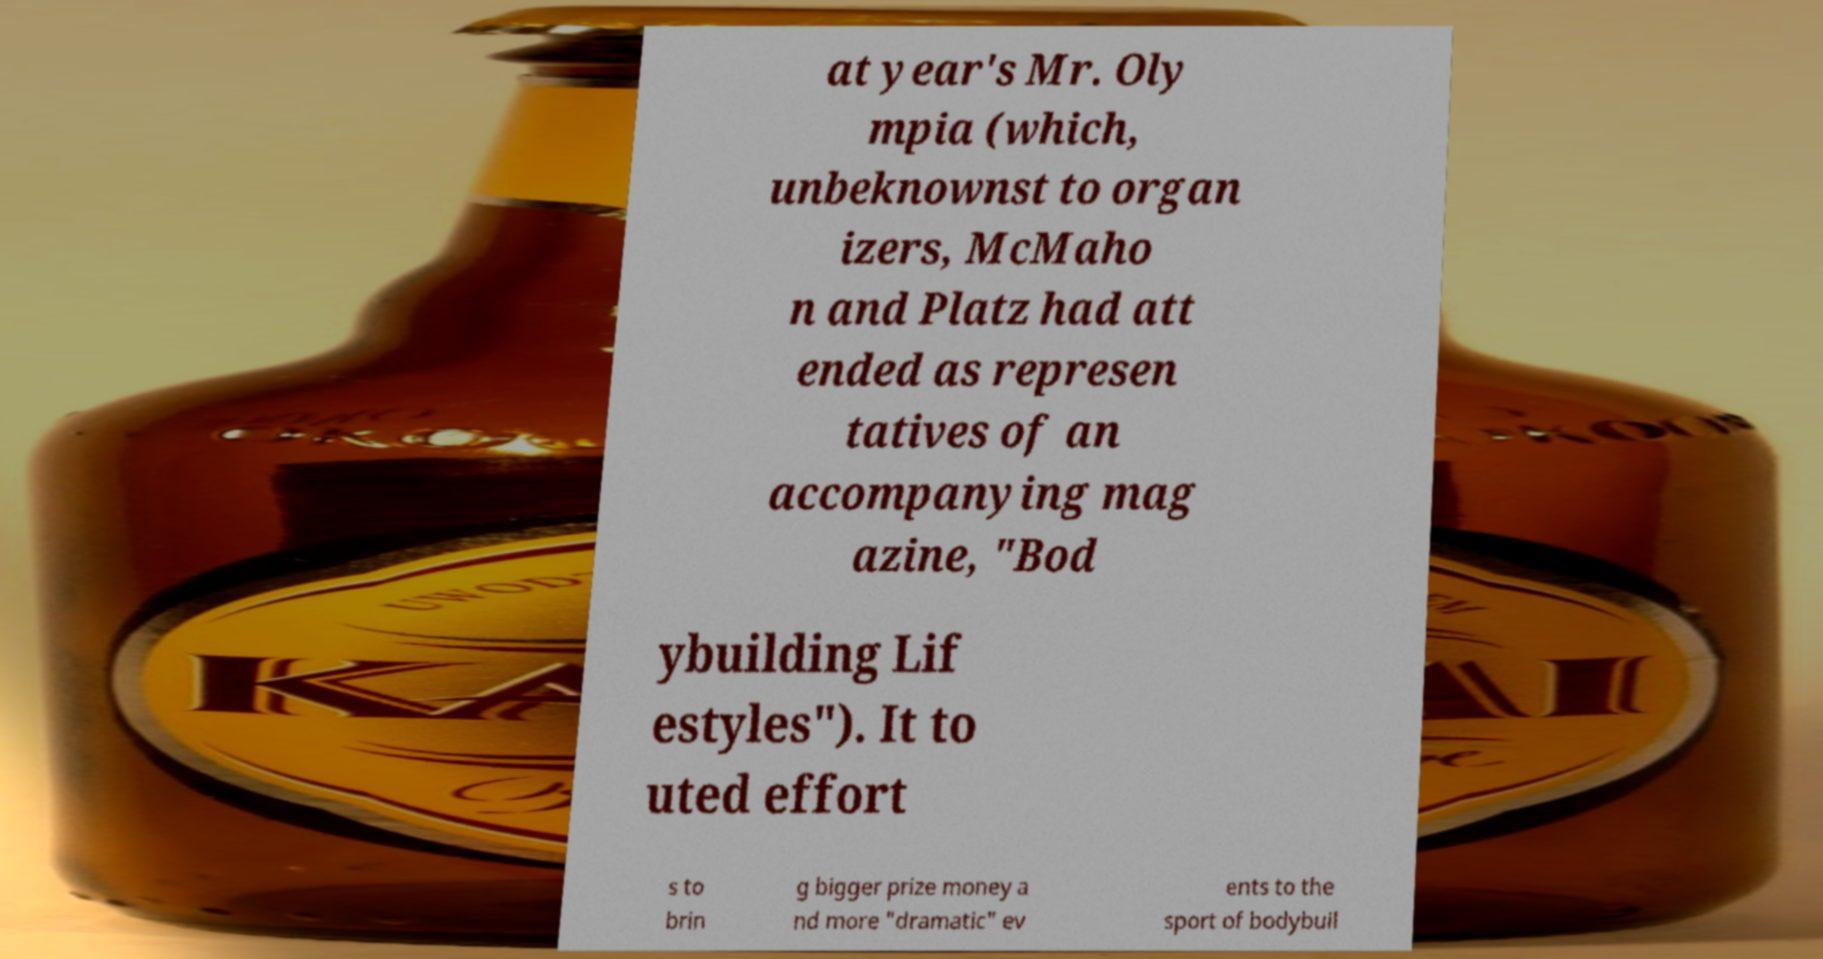There's text embedded in this image that I need extracted. Can you transcribe it verbatim? at year's Mr. Oly mpia (which, unbeknownst to organ izers, McMaho n and Platz had att ended as represen tatives of an accompanying mag azine, "Bod ybuilding Lif estyles"). It to uted effort s to brin g bigger prize money a nd more "dramatic" ev ents to the sport of bodybuil 